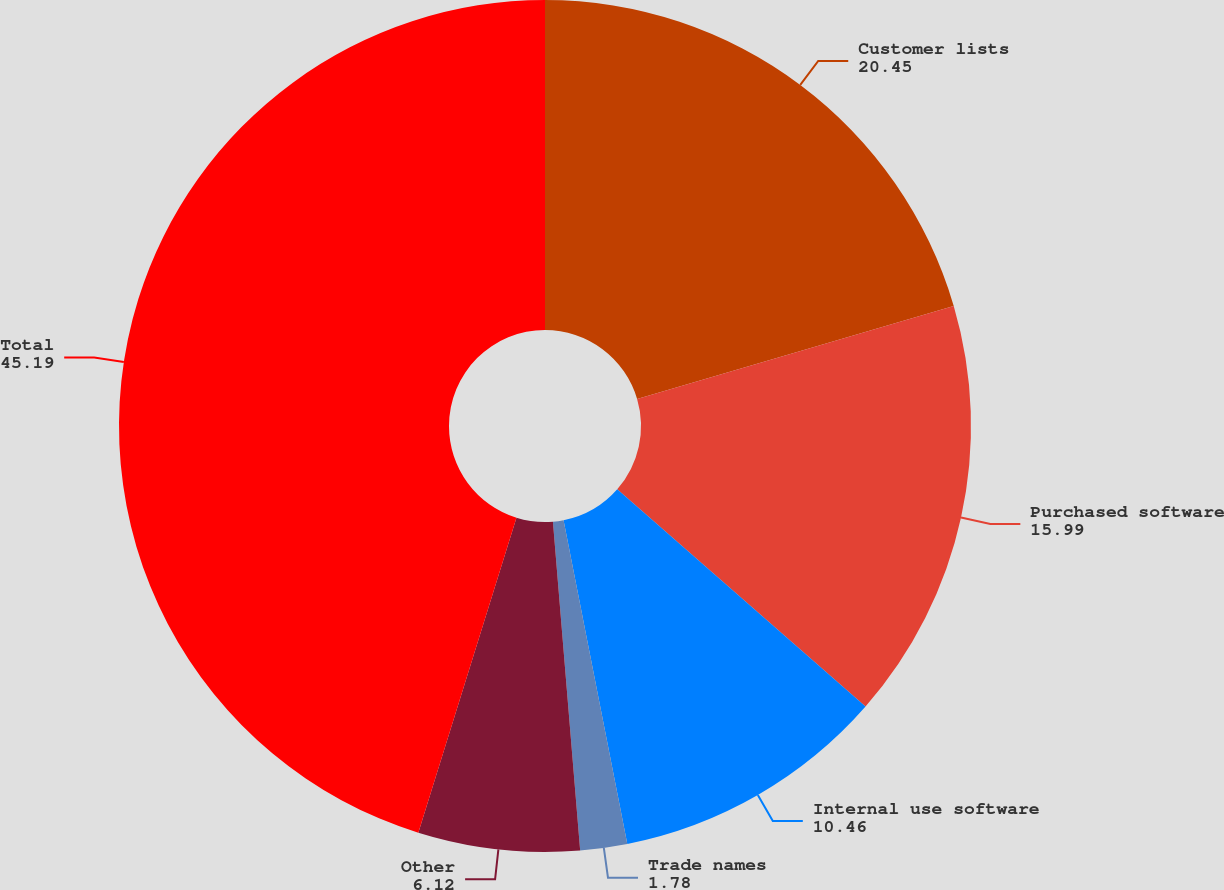Convert chart to OTSL. <chart><loc_0><loc_0><loc_500><loc_500><pie_chart><fcel>Customer lists<fcel>Purchased software<fcel>Internal use software<fcel>Trade names<fcel>Other<fcel>Total<nl><fcel>20.45%<fcel>15.99%<fcel>10.46%<fcel>1.78%<fcel>6.12%<fcel>45.19%<nl></chart> 